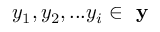<formula> <loc_0><loc_0><loc_500><loc_500>y _ { 1 } , y _ { 2 } , \dots y _ { i } \in y</formula> 